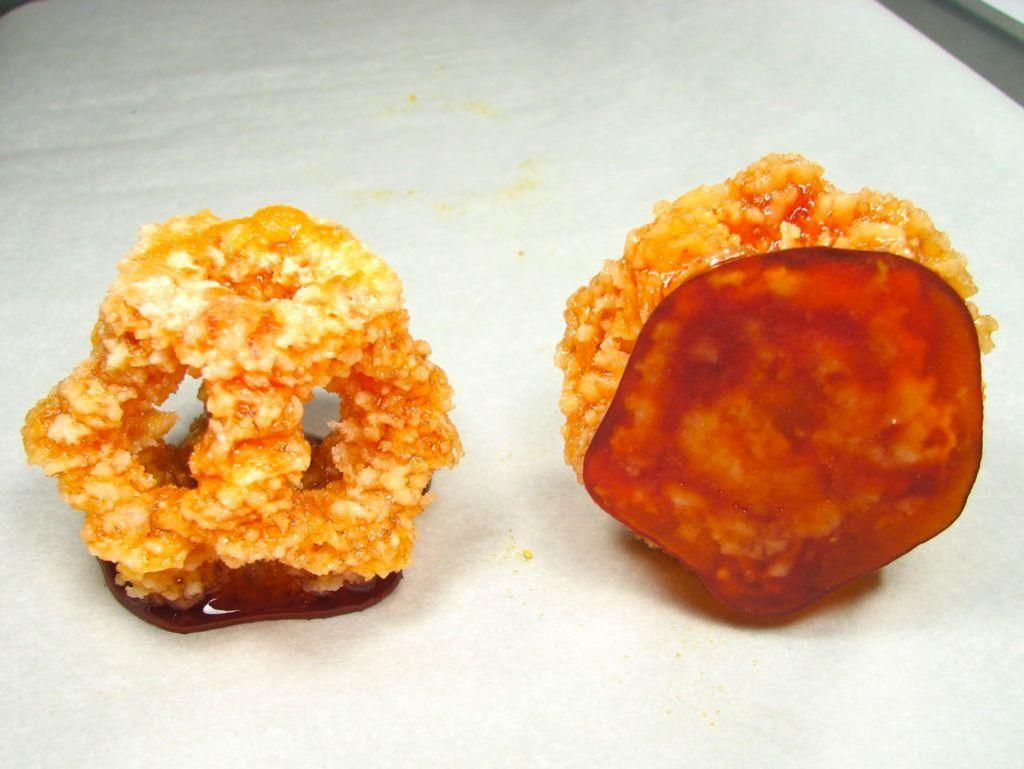What type of objects can be seen in the image? There are food items in the image. What is the color of the object on which the food items are placed? The food items are on a white object. What type of treatment is being administered to the food items in the image? There is no treatment being administered to the food items in the image; they are simply placed on a white object. 